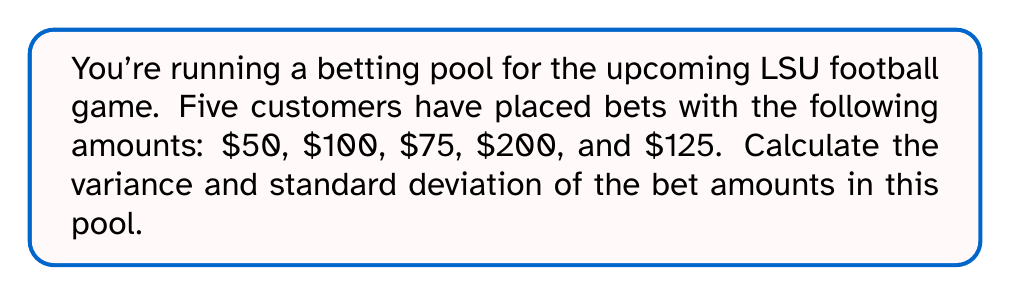Could you help me with this problem? To calculate the variance and standard deviation, we'll follow these steps:

1. Calculate the mean (average) of the bet amounts:
   $$\mu = \frac{50 + 100 + 75 + 200 + 125}{5} = 110$$

2. Calculate the squared differences from the mean:
   $$(50 - 110)^2 = (-60)^2 = 3600$$
   $$(100 - 110)^2 = (-10)^2 = 100$$
   $$(75 - 110)^2 = (-35)^2 = 1225$$
   $$(200 - 110)^2 = 90^2 = 8100$$
   $$(125 - 110)^2 = 15^2 = 225$$

3. Calculate the variance by taking the average of these squared differences:
   $$\text{Variance} = \sigma^2 = \frac{3600 + 100 + 1225 + 8100 + 225}{5} = \frac{13250}{5} = 2650$$

4. Calculate the standard deviation by taking the square root of the variance:
   $$\text{Standard Deviation} = \sigma = \sqrt{2650} = \sqrt{2650} \approx 51.48$$
Answer: Variance: $2650, Standard Deviation: $51.48 